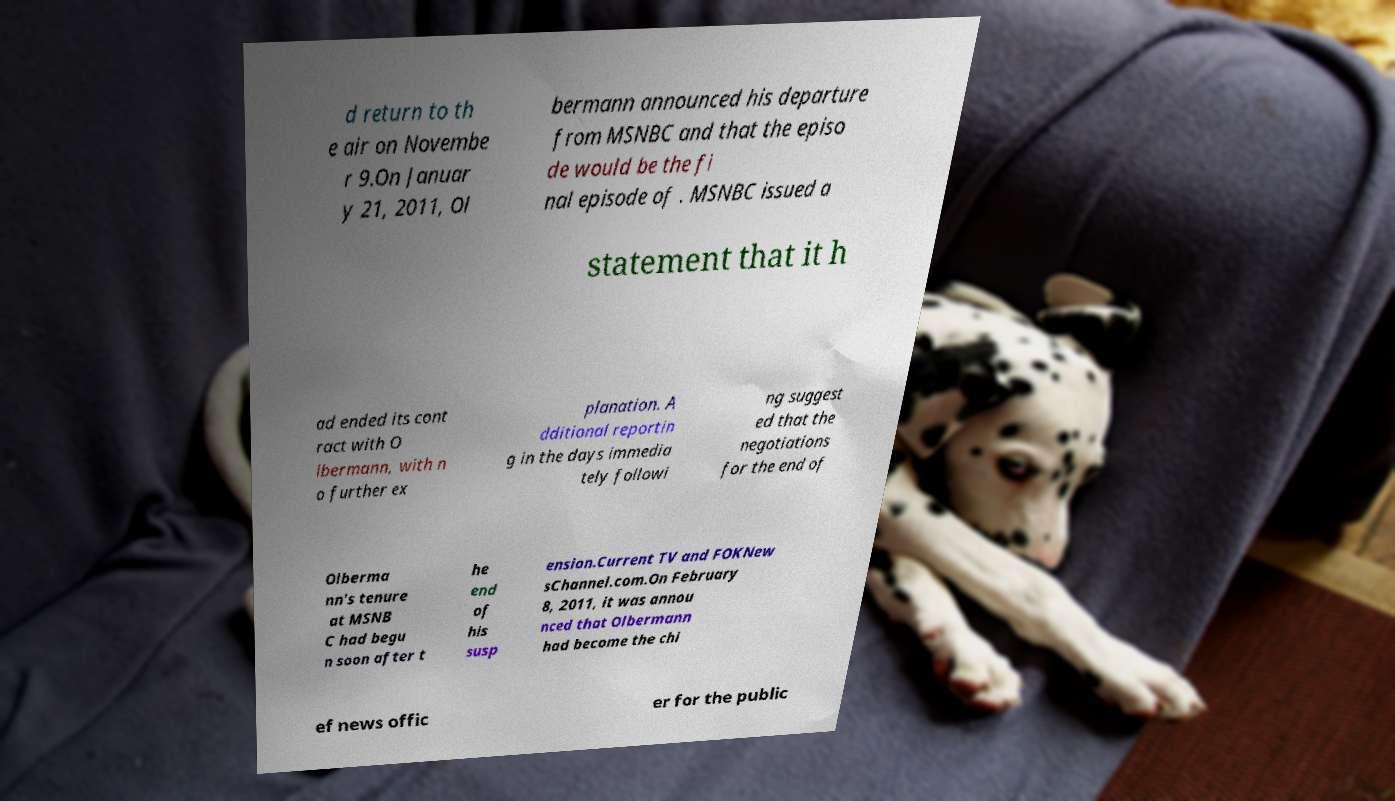I need the written content from this picture converted into text. Can you do that? d return to th e air on Novembe r 9.On Januar y 21, 2011, Ol bermann announced his departure from MSNBC and that the episo de would be the fi nal episode of . MSNBC issued a statement that it h ad ended its cont ract with O lbermann, with n o further ex planation. A dditional reportin g in the days immedia tely followi ng suggest ed that the negotiations for the end of Olberma nn's tenure at MSNB C had begu n soon after t he end of his susp ension.Current TV and FOKNew sChannel.com.On February 8, 2011, it was annou nced that Olbermann had become the chi ef news offic er for the public 